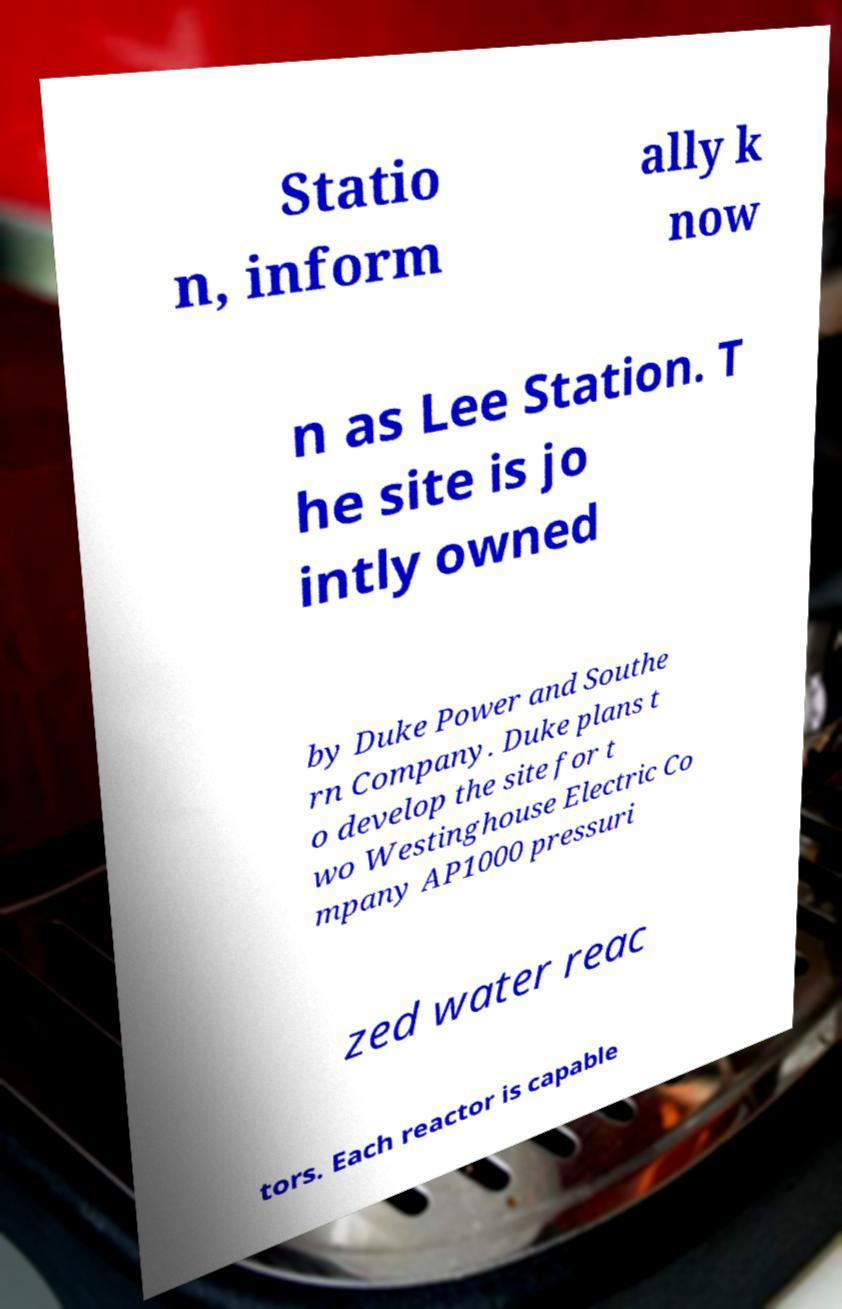For documentation purposes, I need the text within this image transcribed. Could you provide that? Statio n, inform ally k now n as Lee Station. T he site is jo intly owned by Duke Power and Southe rn Company. Duke plans t o develop the site for t wo Westinghouse Electric Co mpany AP1000 pressuri zed water reac tors. Each reactor is capable 